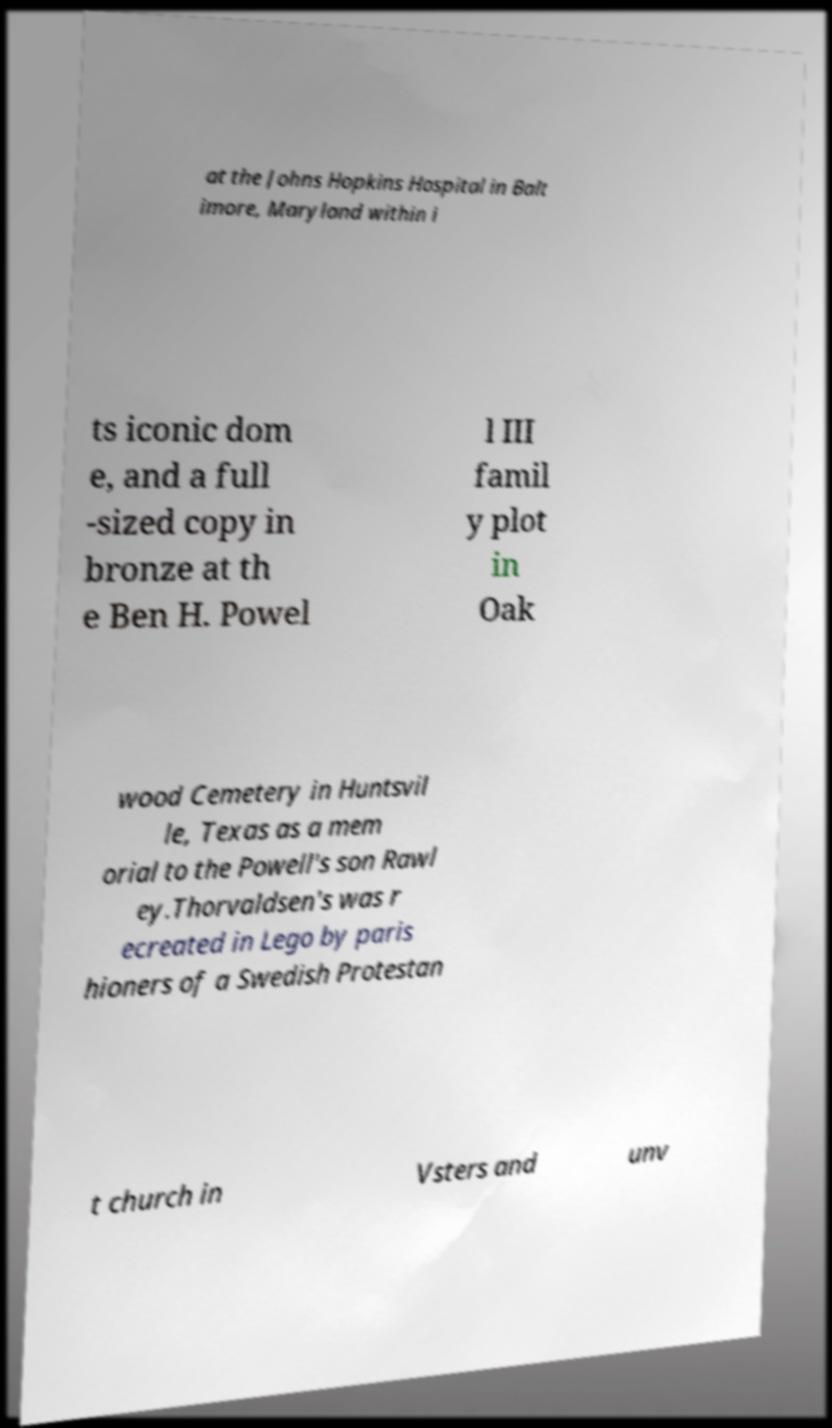Can you accurately transcribe the text from the provided image for me? at the Johns Hopkins Hospital in Balt imore, Maryland within i ts iconic dom e, and a full -sized copy in bronze at th e Ben H. Powel l III famil y plot in Oak wood Cemetery in Huntsvil le, Texas as a mem orial to the Powell's son Rawl ey.Thorvaldsen's was r ecreated in Lego by paris hioners of a Swedish Protestan t church in Vsters and unv 